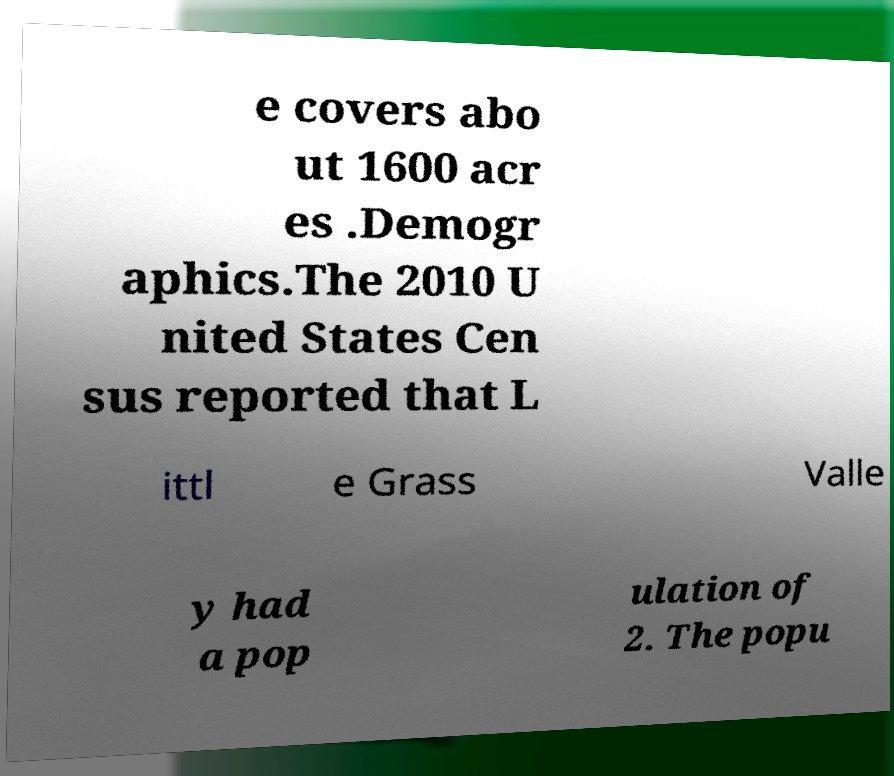What messages or text are displayed in this image? I need them in a readable, typed format. e covers abo ut 1600 acr es .Demogr aphics.The 2010 U nited States Cen sus reported that L ittl e Grass Valle y had a pop ulation of 2. The popu 